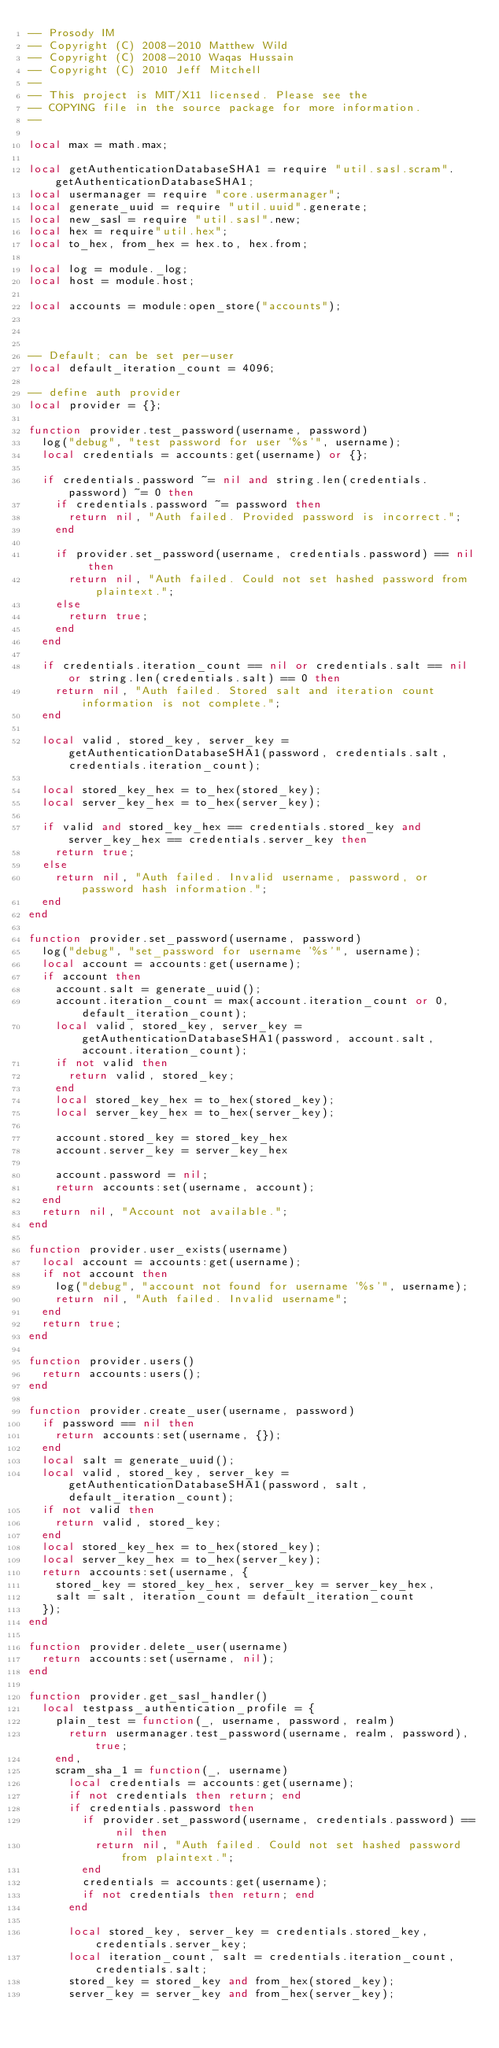<code> <loc_0><loc_0><loc_500><loc_500><_Lua_>-- Prosody IM
-- Copyright (C) 2008-2010 Matthew Wild
-- Copyright (C) 2008-2010 Waqas Hussain
-- Copyright (C) 2010 Jeff Mitchell
--
-- This project is MIT/X11 licensed. Please see the
-- COPYING file in the source package for more information.
--

local max = math.max;

local getAuthenticationDatabaseSHA1 = require "util.sasl.scram".getAuthenticationDatabaseSHA1;
local usermanager = require "core.usermanager";
local generate_uuid = require "util.uuid".generate;
local new_sasl = require "util.sasl".new;
local hex = require"util.hex";
local to_hex, from_hex = hex.to, hex.from;

local log = module._log;
local host = module.host;

local accounts = module:open_store("accounts");



-- Default; can be set per-user
local default_iteration_count = 4096;

-- define auth provider
local provider = {};

function provider.test_password(username, password)
	log("debug", "test password for user '%s'", username);
	local credentials = accounts:get(username) or {};

	if credentials.password ~= nil and string.len(credentials.password) ~= 0 then
		if credentials.password ~= password then
			return nil, "Auth failed. Provided password is incorrect.";
		end

		if provider.set_password(username, credentials.password) == nil then
			return nil, "Auth failed. Could not set hashed password from plaintext.";
		else
			return true;
		end
	end

	if credentials.iteration_count == nil or credentials.salt == nil or string.len(credentials.salt) == 0 then
		return nil, "Auth failed. Stored salt and iteration count information is not complete.";
	end

	local valid, stored_key, server_key = getAuthenticationDatabaseSHA1(password, credentials.salt, credentials.iteration_count);

	local stored_key_hex = to_hex(stored_key);
	local server_key_hex = to_hex(server_key);

	if valid and stored_key_hex == credentials.stored_key and server_key_hex == credentials.server_key then
		return true;
	else
		return nil, "Auth failed. Invalid username, password, or password hash information.";
	end
end

function provider.set_password(username, password)
	log("debug", "set_password for username '%s'", username);
	local account = accounts:get(username);
	if account then
		account.salt = generate_uuid();
		account.iteration_count = max(account.iteration_count or 0, default_iteration_count);
		local valid, stored_key, server_key = getAuthenticationDatabaseSHA1(password, account.salt, account.iteration_count);
		if not valid then
			return valid, stored_key;
		end
		local stored_key_hex = to_hex(stored_key);
		local server_key_hex = to_hex(server_key);

		account.stored_key = stored_key_hex
		account.server_key = server_key_hex

		account.password = nil;
		return accounts:set(username, account);
	end
	return nil, "Account not available.";
end

function provider.user_exists(username)
	local account = accounts:get(username);
	if not account then
		log("debug", "account not found for username '%s'", username);
		return nil, "Auth failed. Invalid username";
	end
	return true;
end

function provider.users()
	return accounts:users();
end

function provider.create_user(username, password)
	if password == nil then
		return accounts:set(username, {});
	end
	local salt = generate_uuid();
	local valid, stored_key, server_key = getAuthenticationDatabaseSHA1(password, salt, default_iteration_count);
	if not valid then
		return valid, stored_key;
	end
	local stored_key_hex = to_hex(stored_key);
	local server_key_hex = to_hex(server_key);
	return accounts:set(username, {
		stored_key = stored_key_hex, server_key = server_key_hex,
		salt = salt, iteration_count = default_iteration_count
	});
end

function provider.delete_user(username)
	return accounts:set(username, nil);
end

function provider.get_sasl_handler()
	local testpass_authentication_profile = {
		plain_test = function(_, username, password, realm)
			return usermanager.test_password(username, realm, password), true;
		end,
		scram_sha_1 = function(_, username)
			local credentials = accounts:get(username);
			if not credentials then return; end
			if credentials.password then
				if provider.set_password(username, credentials.password) == nil then
					return nil, "Auth failed. Could not set hashed password from plaintext.";
				end
				credentials = accounts:get(username);
				if not credentials then return; end
			end

			local stored_key, server_key = credentials.stored_key, credentials.server_key;
			local iteration_count, salt = credentials.iteration_count, credentials.salt;
			stored_key = stored_key and from_hex(stored_key);
			server_key = server_key and from_hex(server_key);</code> 